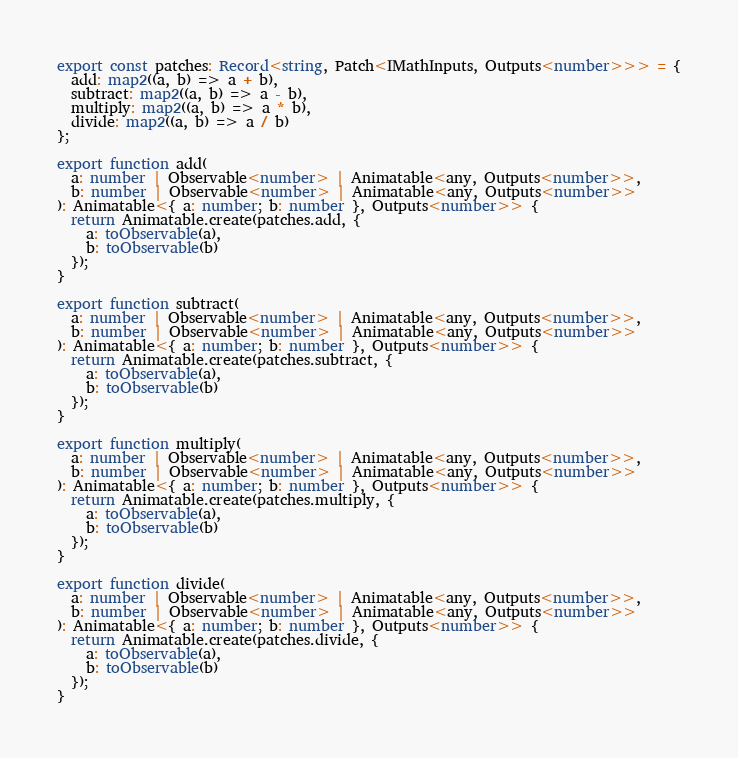<code> <loc_0><loc_0><loc_500><loc_500><_TypeScript_>export const patches: Record<string, Patch<IMathInputs, Outputs<number>>> = {
  add: map2((a, b) => a + b),
  subtract: map2((a, b) => a - b),
  multiply: map2((a, b) => a * b),
  divide: map2((a, b) => a / b)
};

export function add(
  a: number | Observable<number> | Animatable<any, Outputs<number>>,
  b: number | Observable<number> | Animatable<any, Outputs<number>>
): Animatable<{ a: number; b: number }, Outputs<number>> {
  return Animatable.create(patches.add, {
    a: toObservable(a),
    b: toObservable(b)
  });
}

export function subtract(
  a: number | Observable<number> | Animatable<any, Outputs<number>>,
  b: number | Observable<number> | Animatable<any, Outputs<number>>
): Animatable<{ a: number; b: number }, Outputs<number>> {
  return Animatable.create(patches.subtract, {
    a: toObservable(a),
    b: toObservable(b)
  });
}

export function multiply(
  a: number | Observable<number> | Animatable<any, Outputs<number>>,
  b: number | Observable<number> | Animatable<any, Outputs<number>>
): Animatable<{ a: number; b: number }, Outputs<number>> {
  return Animatable.create(patches.multiply, {
    a: toObservable(a),
    b: toObservable(b)
  });
}

export function divide(
  a: number | Observable<number> | Animatable<any, Outputs<number>>,
  b: number | Observable<number> | Animatable<any, Outputs<number>>
): Animatable<{ a: number; b: number }, Outputs<number>> {
  return Animatable.create(patches.divide, {
    a: toObservable(a),
    b: toObservable(b)
  });
}
</code> 